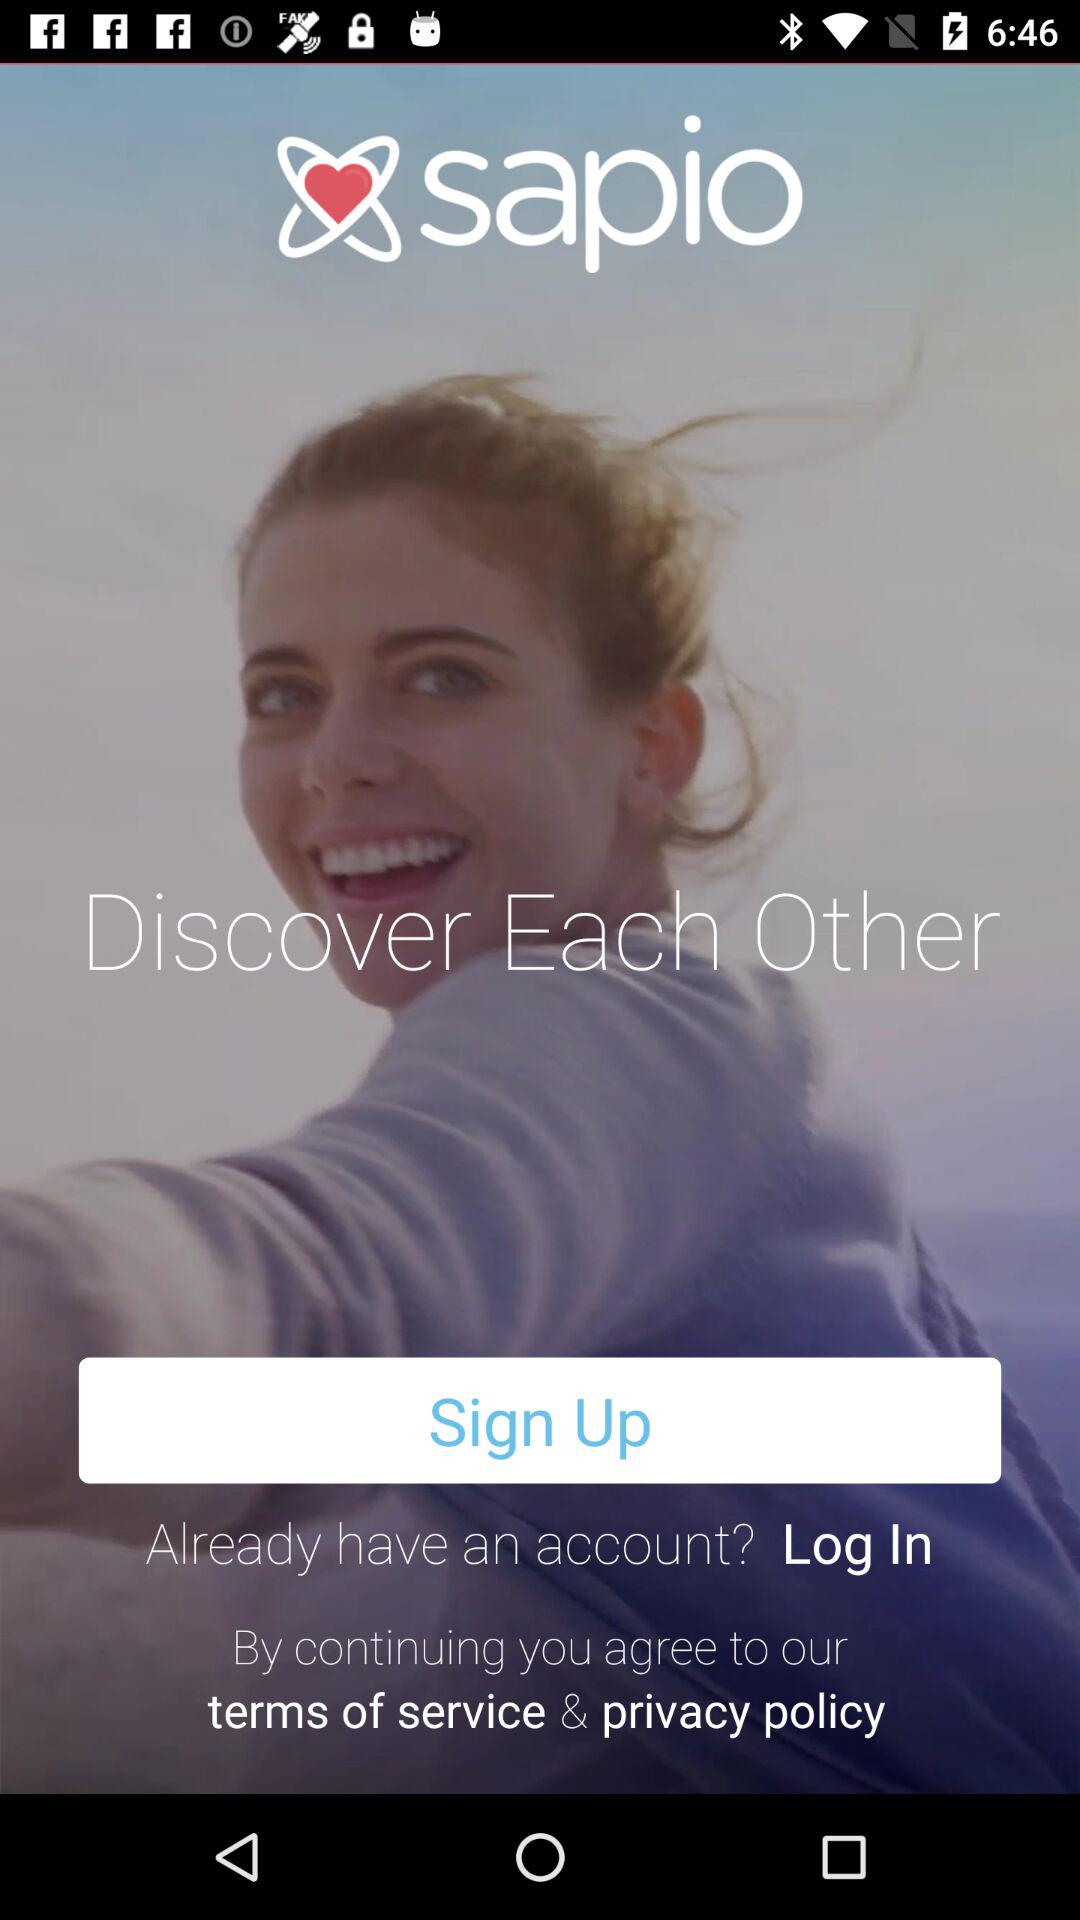What is the app name? The app name is "sapio". 